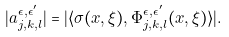<formula> <loc_0><loc_0><loc_500><loc_500>| a ^ { \epsilon , \epsilon ^ { \prime } } _ { j , k , l } | = | \langle \sigma ( x , \xi ) , \Phi ^ { \epsilon , \epsilon ^ { \prime } } _ { j , k , l } ( x , \xi ) \rangle | .</formula> 